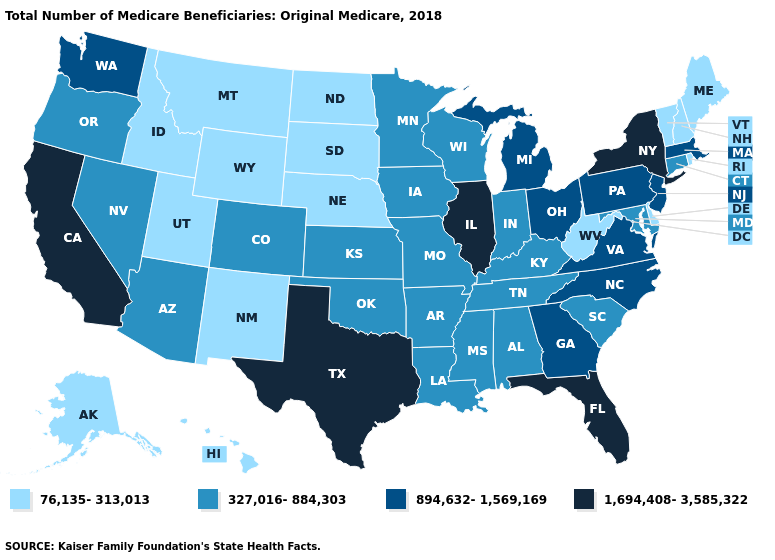What is the value of Arizona?
Give a very brief answer. 327,016-884,303. Which states hav the highest value in the West?
Give a very brief answer. California. Does Texas have the highest value in the South?
Keep it brief. Yes. What is the highest value in the Northeast ?
Be succinct. 1,694,408-3,585,322. What is the value of Iowa?
Keep it brief. 327,016-884,303. Does the map have missing data?
Short answer required. No. Name the states that have a value in the range 894,632-1,569,169?
Short answer required. Georgia, Massachusetts, Michigan, New Jersey, North Carolina, Ohio, Pennsylvania, Virginia, Washington. How many symbols are there in the legend?
Keep it brief. 4. Does Tennessee have a lower value than Ohio?
Give a very brief answer. Yes. What is the value of New York?
Concise answer only. 1,694,408-3,585,322. What is the value of Wyoming?
Quick response, please. 76,135-313,013. Which states have the lowest value in the Northeast?
Answer briefly. Maine, New Hampshire, Rhode Island, Vermont. Name the states that have a value in the range 894,632-1,569,169?
Short answer required. Georgia, Massachusetts, Michigan, New Jersey, North Carolina, Ohio, Pennsylvania, Virginia, Washington. Name the states that have a value in the range 894,632-1,569,169?
Keep it brief. Georgia, Massachusetts, Michigan, New Jersey, North Carolina, Ohio, Pennsylvania, Virginia, Washington. What is the value of New Hampshire?
Short answer required. 76,135-313,013. 